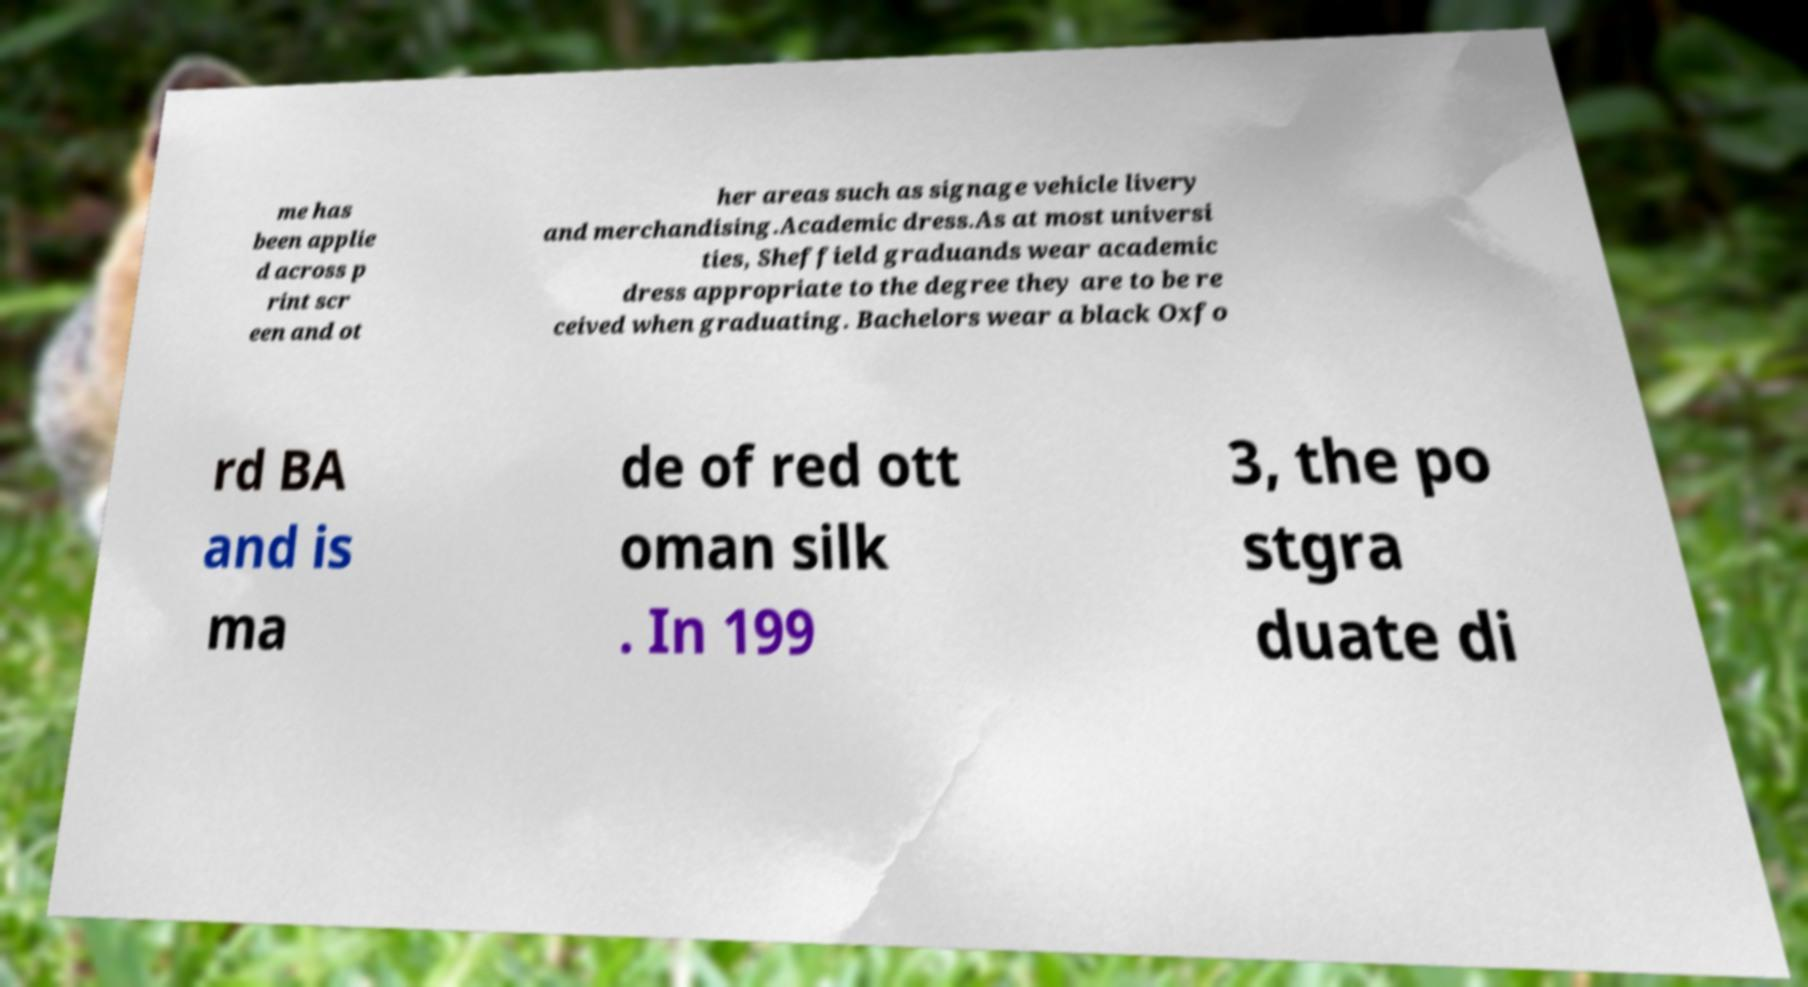What messages or text are displayed in this image? I need them in a readable, typed format. me has been applie d across p rint scr een and ot her areas such as signage vehicle livery and merchandising.Academic dress.As at most universi ties, Sheffield graduands wear academic dress appropriate to the degree they are to be re ceived when graduating. Bachelors wear a black Oxfo rd BA and is ma de of red ott oman silk . In 199 3, the po stgra duate di 